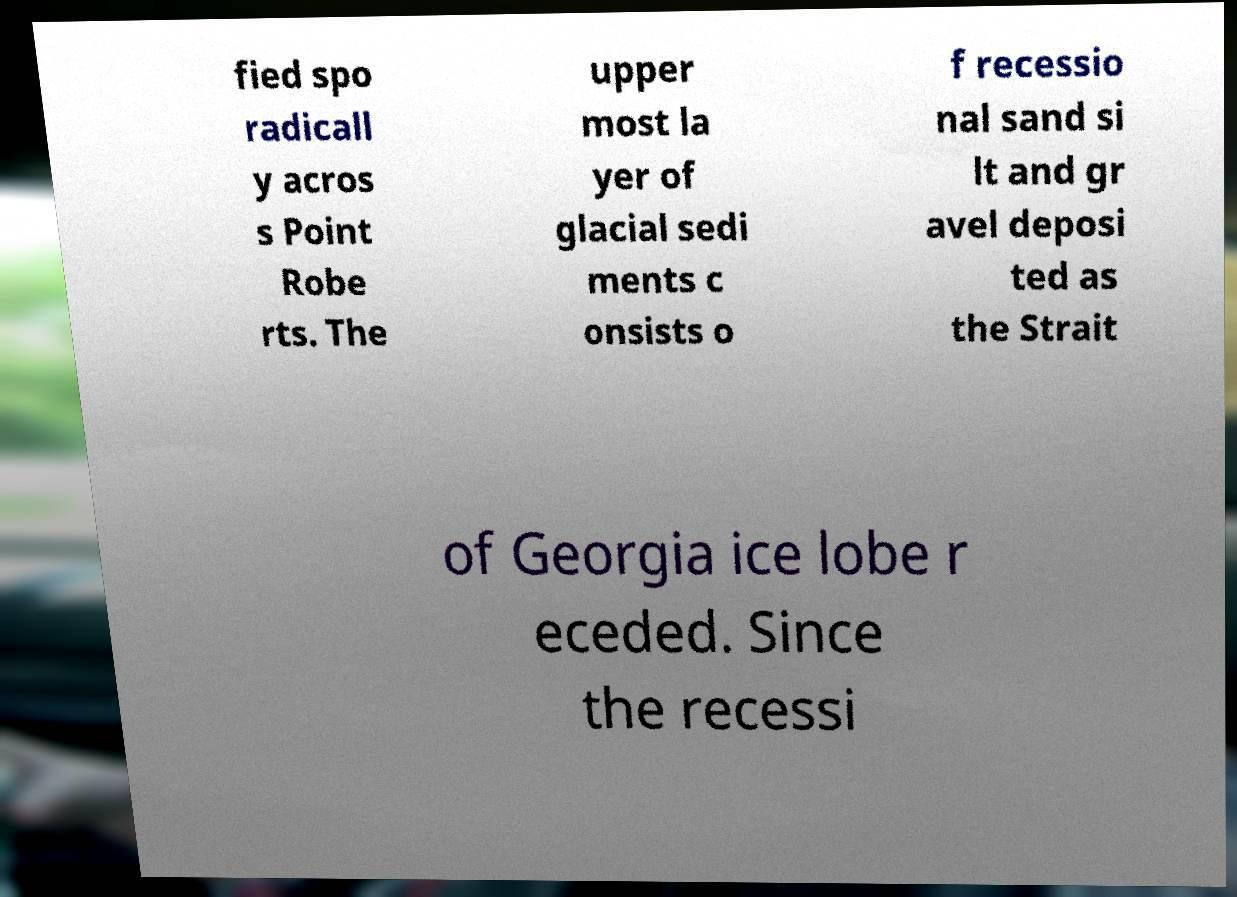Can you read and provide the text displayed in the image?This photo seems to have some interesting text. Can you extract and type it out for me? fied spo radicall y acros s Point Robe rts. The upper most la yer of glacial sedi ments c onsists o f recessio nal sand si lt and gr avel deposi ted as the Strait of Georgia ice lobe r eceded. Since the recessi 